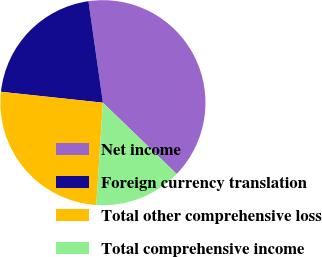<chart> <loc_0><loc_0><loc_500><loc_500><pie_chart><fcel>Net income<fcel>Foreign currency translation<fcel>Total other comprehensive loss<fcel>Total comprehensive income<nl><fcel>39.48%<fcel>21.05%<fcel>25.67%<fcel>13.8%<nl></chart> 